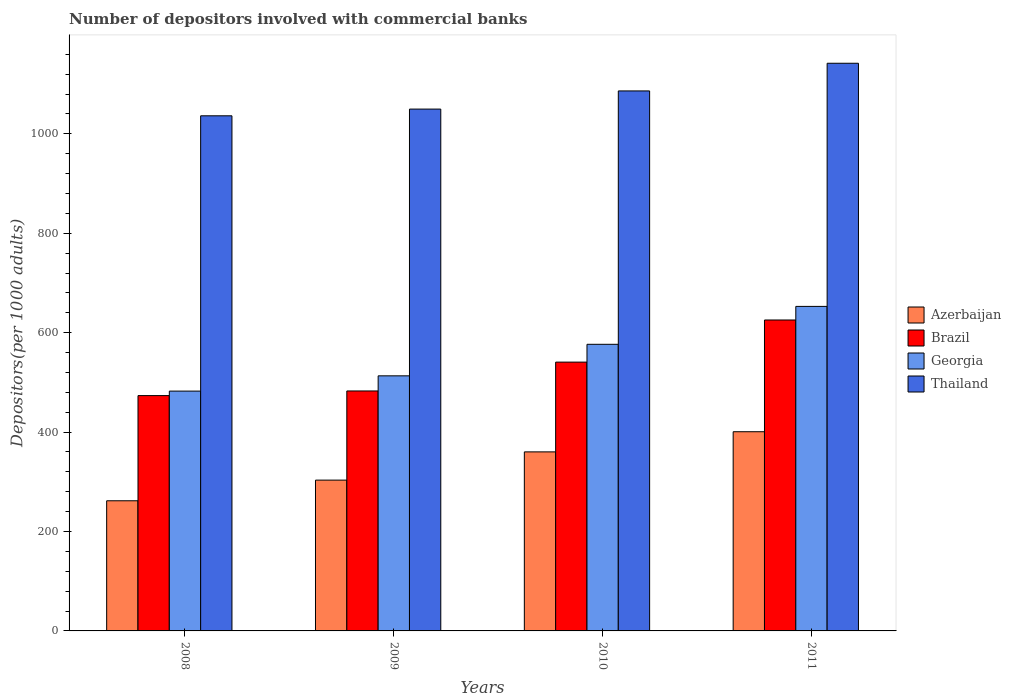How many different coloured bars are there?
Provide a short and direct response. 4. Are the number of bars on each tick of the X-axis equal?
Your answer should be very brief. Yes. How many bars are there on the 4th tick from the left?
Give a very brief answer. 4. In how many cases, is the number of bars for a given year not equal to the number of legend labels?
Ensure brevity in your answer.  0. What is the number of depositors involved with commercial banks in Thailand in 2010?
Provide a short and direct response. 1086.36. Across all years, what is the maximum number of depositors involved with commercial banks in Georgia?
Make the answer very short. 652.89. Across all years, what is the minimum number of depositors involved with commercial banks in Georgia?
Your answer should be compact. 482.47. In which year was the number of depositors involved with commercial banks in Brazil maximum?
Give a very brief answer. 2011. What is the total number of depositors involved with commercial banks in Brazil in the graph?
Make the answer very short. 2122.49. What is the difference between the number of depositors involved with commercial banks in Azerbaijan in 2010 and that in 2011?
Your answer should be very brief. -40.54. What is the difference between the number of depositors involved with commercial banks in Thailand in 2008 and the number of depositors involved with commercial banks in Brazil in 2009?
Your answer should be compact. 553.57. What is the average number of depositors involved with commercial banks in Azerbaijan per year?
Provide a short and direct response. 331.54. In the year 2009, what is the difference between the number of depositors involved with commercial banks in Thailand and number of depositors involved with commercial banks in Azerbaijan?
Provide a succinct answer. 746.44. What is the ratio of the number of depositors involved with commercial banks in Azerbaijan in 2008 to that in 2010?
Offer a terse response. 0.73. Is the number of depositors involved with commercial banks in Azerbaijan in 2008 less than that in 2011?
Offer a very short reply. Yes. What is the difference between the highest and the second highest number of depositors involved with commercial banks in Brazil?
Your answer should be compact. 84.74. What is the difference between the highest and the lowest number of depositors involved with commercial banks in Georgia?
Provide a short and direct response. 170.42. In how many years, is the number of depositors involved with commercial banks in Brazil greater than the average number of depositors involved with commercial banks in Brazil taken over all years?
Provide a succinct answer. 2. Is the sum of the number of depositors involved with commercial banks in Brazil in 2008 and 2011 greater than the maximum number of depositors involved with commercial banks in Azerbaijan across all years?
Make the answer very short. Yes. What does the 2nd bar from the right in 2011 represents?
Your response must be concise. Georgia. Does the graph contain any zero values?
Your answer should be compact. No. Does the graph contain grids?
Make the answer very short. No. How many legend labels are there?
Offer a very short reply. 4. How are the legend labels stacked?
Ensure brevity in your answer.  Vertical. What is the title of the graph?
Give a very brief answer. Number of depositors involved with commercial banks. Does "Jamaica" appear as one of the legend labels in the graph?
Provide a succinct answer. No. What is the label or title of the X-axis?
Provide a short and direct response. Years. What is the label or title of the Y-axis?
Your answer should be very brief. Depositors(per 1000 adults). What is the Depositors(per 1000 adults) of Azerbaijan in 2008?
Your response must be concise. 261.83. What is the Depositors(per 1000 adults) of Brazil in 2008?
Make the answer very short. 473.42. What is the Depositors(per 1000 adults) in Georgia in 2008?
Keep it short and to the point. 482.47. What is the Depositors(per 1000 adults) of Thailand in 2008?
Give a very brief answer. 1036.31. What is the Depositors(per 1000 adults) in Azerbaijan in 2009?
Provide a short and direct response. 303.38. What is the Depositors(per 1000 adults) in Brazil in 2009?
Offer a very short reply. 482.74. What is the Depositors(per 1000 adults) in Georgia in 2009?
Ensure brevity in your answer.  513.17. What is the Depositors(per 1000 adults) in Thailand in 2009?
Make the answer very short. 1049.83. What is the Depositors(per 1000 adults) of Azerbaijan in 2010?
Offer a terse response. 360.2. What is the Depositors(per 1000 adults) of Brazil in 2010?
Make the answer very short. 540.79. What is the Depositors(per 1000 adults) in Georgia in 2010?
Provide a succinct answer. 576.61. What is the Depositors(per 1000 adults) in Thailand in 2010?
Keep it short and to the point. 1086.36. What is the Depositors(per 1000 adults) of Azerbaijan in 2011?
Your answer should be very brief. 400.73. What is the Depositors(per 1000 adults) in Brazil in 2011?
Keep it short and to the point. 625.53. What is the Depositors(per 1000 adults) of Georgia in 2011?
Make the answer very short. 652.89. What is the Depositors(per 1000 adults) of Thailand in 2011?
Your answer should be compact. 1142.03. Across all years, what is the maximum Depositors(per 1000 adults) of Azerbaijan?
Offer a very short reply. 400.73. Across all years, what is the maximum Depositors(per 1000 adults) of Brazil?
Keep it short and to the point. 625.53. Across all years, what is the maximum Depositors(per 1000 adults) of Georgia?
Your answer should be very brief. 652.89. Across all years, what is the maximum Depositors(per 1000 adults) of Thailand?
Give a very brief answer. 1142.03. Across all years, what is the minimum Depositors(per 1000 adults) of Azerbaijan?
Your response must be concise. 261.83. Across all years, what is the minimum Depositors(per 1000 adults) of Brazil?
Provide a short and direct response. 473.42. Across all years, what is the minimum Depositors(per 1000 adults) of Georgia?
Ensure brevity in your answer.  482.47. Across all years, what is the minimum Depositors(per 1000 adults) of Thailand?
Keep it short and to the point. 1036.31. What is the total Depositors(per 1000 adults) of Azerbaijan in the graph?
Make the answer very short. 1326.14. What is the total Depositors(per 1000 adults) in Brazil in the graph?
Offer a terse response. 2122.49. What is the total Depositors(per 1000 adults) of Georgia in the graph?
Keep it short and to the point. 2225.13. What is the total Depositors(per 1000 adults) in Thailand in the graph?
Provide a succinct answer. 4314.52. What is the difference between the Depositors(per 1000 adults) in Azerbaijan in 2008 and that in 2009?
Make the answer very short. -41.55. What is the difference between the Depositors(per 1000 adults) in Brazil in 2008 and that in 2009?
Provide a short and direct response. -9.32. What is the difference between the Depositors(per 1000 adults) of Georgia in 2008 and that in 2009?
Make the answer very short. -30.7. What is the difference between the Depositors(per 1000 adults) of Thailand in 2008 and that in 2009?
Keep it short and to the point. -13.52. What is the difference between the Depositors(per 1000 adults) of Azerbaijan in 2008 and that in 2010?
Keep it short and to the point. -98.36. What is the difference between the Depositors(per 1000 adults) of Brazil in 2008 and that in 2010?
Make the answer very short. -67.37. What is the difference between the Depositors(per 1000 adults) in Georgia in 2008 and that in 2010?
Provide a succinct answer. -94.14. What is the difference between the Depositors(per 1000 adults) in Thailand in 2008 and that in 2010?
Your answer should be compact. -50.05. What is the difference between the Depositors(per 1000 adults) in Azerbaijan in 2008 and that in 2011?
Give a very brief answer. -138.9. What is the difference between the Depositors(per 1000 adults) of Brazil in 2008 and that in 2011?
Your answer should be compact. -152.11. What is the difference between the Depositors(per 1000 adults) in Georgia in 2008 and that in 2011?
Provide a succinct answer. -170.42. What is the difference between the Depositors(per 1000 adults) of Thailand in 2008 and that in 2011?
Your answer should be compact. -105.72. What is the difference between the Depositors(per 1000 adults) of Azerbaijan in 2009 and that in 2010?
Offer a terse response. -56.81. What is the difference between the Depositors(per 1000 adults) of Brazil in 2009 and that in 2010?
Your answer should be compact. -58.05. What is the difference between the Depositors(per 1000 adults) in Georgia in 2009 and that in 2010?
Provide a succinct answer. -63.44. What is the difference between the Depositors(per 1000 adults) of Thailand in 2009 and that in 2010?
Offer a terse response. -36.53. What is the difference between the Depositors(per 1000 adults) in Azerbaijan in 2009 and that in 2011?
Your answer should be very brief. -97.35. What is the difference between the Depositors(per 1000 adults) in Brazil in 2009 and that in 2011?
Keep it short and to the point. -142.79. What is the difference between the Depositors(per 1000 adults) of Georgia in 2009 and that in 2011?
Offer a terse response. -139.72. What is the difference between the Depositors(per 1000 adults) in Thailand in 2009 and that in 2011?
Ensure brevity in your answer.  -92.2. What is the difference between the Depositors(per 1000 adults) of Azerbaijan in 2010 and that in 2011?
Provide a succinct answer. -40.54. What is the difference between the Depositors(per 1000 adults) of Brazil in 2010 and that in 2011?
Keep it short and to the point. -84.74. What is the difference between the Depositors(per 1000 adults) in Georgia in 2010 and that in 2011?
Give a very brief answer. -76.28. What is the difference between the Depositors(per 1000 adults) in Thailand in 2010 and that in 2011?
Provide a succinct answer. -55.66. What is the difference between the Depositors(per 1000 adults) in Azerbaijan in 2008 and the Depositors(per 1000 adults) in Brazil in 2009?
Offer a very short reply. -220.91. What is the difference between the Depositors(per 1000 adults) in Azerbaijan in 2008 and the Depositors(per 1000 adults) in Georgia in 2009?
Offer a terse response. -251.33. What is the difference between the Depositors(per 1000 adults) in Azerbaijan in 2008 and the Depositors(per 1000 adults) in Thailand in 2009?
Give a very brief answer. -788. What is the difference between the Depositors(per 1000 adults) in Brazil in 2008 and the Depositors(per 1000 adults) in Georgia in 2009?
Give a very brief answer. -39.74. What is the difference between the Depositors(per 1000 adults) in Brazil in 2008 and the Depositors(per 1000 adults) in Thailand in 2009?
Provide a succinct answer. -576.41. What is the difference between the Depositors(per 1000 adults) in Georgia in 2008 and the Depositors(per 1000 adults) in Thailand in 2009?
Ensure brevity in your answer.  -567.36. What is the difference between the Depositors(per 1000 adults) of Azerbaijan in 2008 and the Depositors(per 1000 adults) of Brazil in 2010?
Make the answer very short. -278.96. What is the difference between the Depositors(per 1000 adults) in Azerbaijan in 2008 and the Depositors(per 1000 adults) in Georgia in 2010?
Your answer should be very brief. -314.78. What is the difference between the Depositors(per 1000 adults) of Azerbaijan in 2008 and the Depositors(per 1000 adults) of Thailand in 2010?
Your answer should be very brief. -824.53. What is the difference between the Depositors(per 1000 adults) in Brazil in 2008 and the Depositors(per 1000 adults) in Georgia in 2010?
Offer a very short reply. -103.19. What is the difference between the Depositors(per 1000 adults) in Brazil in 2008 and the Depositors(per 1000 adults) in Thailand in 2010?
Your answer should be compact. -612.94. What is the difference between the Depositors(per 1000 adults) in Georgia in 2008 and the Depositors(per 1000 adults) in Thailand in 2010?
Your answer should be compact. -603.89. What is the difference between the Depositors(per 1000 adults) in Azerbaijan in 2008 and the Depositors(per 1000 adults) in Brazil in 2011?
Offer a very short reply. -363.7. What is the difference between the Depositors(per 1000 adults) of Azerbaijan in 2008 and the Depositors(per 1000 adults) of Georgia in 2011?
Give a very brief answer. -391.05. What is the difference between the Depositors(per 1000 adults) in Azerbaijan in 2008 and the Depositors(per 1000 adults) in Thailand in 2011?
Offer a terse response. -880.19. What is the difference between the Depositors(per 1000 adults) of Brazil in 2008 and the Depositors(per 1000 adults) of Georgia in 2011?
Ensure brevity in your answer.  -179.46. What is the difference between the Depositors(per 1000 adults) in Brazil in 2008 and the Depositors(per 1000 adults) in Thailand in 2011?
Offer a very short reply. -668.6. What is the difference between the Depositors(per 1000 adults) of Georgia in 2008 and the Depositors(per 1000 adults) of Thailand in 2011?
Ensure brevity in your answer.  -659.56. What is the difference between the Depositors(per 1000 adults) of Azerbaijan in 2009 and the Depositors(per 1000 adults) of Brazil in 2010?
Your answer should be compact. -237.41. What is the difference between the Depositors(per 1000 adults) in Azerbaijan in 2009 and the Depositors(per 1000 adults) in Georgia in 2010?
Make the answer very short. -273.22. What is the difference between the Depositors(per 1000 adults) in Azerbaijan in 2009 and the Depositors(per 1000 adults) in Thailand in 2010?
Make the answer very short. -782.98. What is the difference between the Depositors(per 1000 adults) of Brazil in 2009 and the Depositors(per 1000 adults) of Georgia in 2010?
Provide a short and direct response. -93.87. What is the difference between the Depositors(per 1000 adults) of Brazil in 2009 and the Depositors(per 1000 adults) of Thailand in 2010?
Your response must be concise. -603.62. What is the difference between the Depositors(per 1000 adults) in Georgia in 2009 and the Depositors(per 1000 adults) in Thailand in 2010?
Your answer should be compact. -573.2. What is the difference between the Depositors(per 1000 adults) of Azerbaijan in 2009 and the Depositors(per 1000 adults) of Brazil in 2011?
Your response must be concise. -322.15. What is the difference between the Depositors(per 1000 adults) of Azerbaijan in 2009 and the Depositors(per 1000 adults) of Georgia in 2011?
Keep it short and to the point. -349.5. What is the difference between the Depositors(per 1000 adults) of Azerbaijan in 2009 and the Depositors(per 1000 adults) of Thailand in 2011?
Your answer should be very brief. -838.64. What is the difference between the Depositors(per 1000 adults) of Brazil in 2009 and the Depositors(per 1000 adults) of Georgia in 2011?
Make the answer very short. -170.15. What is the difference between the Depositors(per 1000 adults) of Brazil in 2009 and the Depositors(per 1000 adults) of Thailand in 2011?
Ensure brevity in your answer.  -659.29. What is the difference between the Depositors(per 1000 adults) of Georgia in 2009 and the Depositors(per 1000 adults) of Thailand in 2011?
Keep it short and to the point. -628.86. What is the difference between the Depositors(per 1000 adults) in Azerbaijan in 2010 and the Depositors(per 1000 adults) in Brazil in 2011?
Provide a succinct answer. -265.34. What is the difference between the Depositors(per 1000 adults) of Azerbaijan in 2010 and the Depositors(per 1000 adults) of Georgia in 2011?
Ensure brevity in your answer.  -292.69. What is the difference between the Depositors(per 1000 adults) of Azerbaijan in 2010 and the Depositors(per 1000 adults) of Thailand in 2011?
Give a very brief answer. -781.83. What is the difference between the Depositors(per 1000 adults) in Brazil in 2010 and the Depositors(per 1000 adults) in Georgia in 2011?
Offer a terse response. -112.09. What is the difference between the Depositors(per 1000 adults) of Brazil in 2010 and the Depositors(per 1000 adults) of Thailand in 2011?
Make the answer very short. -601.23. What is the difference between the Depositors(per 1000 adults) of Georgia in 2010 and the Depositors(per 1000 adults) of Thailand in 2011?
Your answer should be compact. -565.42. What is the average Depositors(per 1000 adults) of Azerbaijan per year?
Keep it short and to the point. 331.54. What is the average Depositors(per 1000 adults) in Brazil per year?
Your response must be concise. 530.62. What is the average Depositors(per 1000 adults) in Georgia per year?
Keep it short and to the point. 556.28. What is the average Depositors(per 1000 adults) of Thailand per year?
Offer a terse response. 1078.63. In the year 2008, what is the difference between the Depositors(per 1000 adults) in Azerbaijan and Depositors(per 1000 adults) in Brazil?
Give a very brief answer. -211.59. In the year 2008, what is the difference between the Depositors(per 1000 adults) of Azerbaijan and Depositors(per 1000 adults) of Georgia?
Ensure brevity in your answer.  -220.64. In the year 2008, what is the difference between the Depositors(per 1000 adults) in Azerbaijan and Depositors(per 1000 adults) in Thailand?
Offer a very short reply. -774.48. In the year 2008, what is the difference between the Depositors(per 1000 adults) in Brazil and Depositors(per 1000 adults) in Georgia?
Offer a terse response. -9.05. In the year 2008, what is the difference between the Depositors(per 1000 adults) in Brazil and Depositors(per 1000 adults) in Thailand?
Offer a very short reply. -562.89. In the year 2008, what is the difference between the Depositors(per 1000 adults) of Georgia and Depositors(per 1000 adults) of Thailand?
Provide a short and direct response. -553.84. In the year 2009, what is the difference between the Depositors(per 1000 adults) of Azerbaijan and Depositors(per 1000 adults) of Brazil?
Keep it short and to the point. -179.36. In the year 2009, what is the difference between the Depositors(per 1000 adults) of Azerbaijan and Depositors(per 1000 adults) of Georgia?
Offer a very short reply. -209.78. In the year 2009, what is the difference between the Depositors(per 1000 adults) of Azerbaijan and Depositors(per 1000 adults) of Thailand?
Make the answer very short. -746.44. In the year 2009, what is the difference between the Depositors(per 1000 adults) in Brazil and Depositors(per 1000 adults) in Georgia?
Your answer should be compact. -30.43. In the year 2009, what is the difference between the Depositors(per 1000 adults) of Brazil and Depositors(per 1000 adults) of Thailand?
Offer a terse response. -567.09. In the year 2009, what is the difference between the Depositors(per 1000 adults) in Georgia and Depositors(per 1000 adults) in Thailand?
Provide a succinct answer. -536.66. In the year 2010, what is the difference between the Depositors(per 1000 adults) in Azerbaijan and Depositors(per 1000 adults) in Brazil?
Give a very brief answer. -180.6. In the year 2010, what is the difference between the Depositors(per 1000 adults) of Azerbaijan and Depositors(per 1000 adults) of Georgia?
Provide a succinct answer. -216.41. In the year 2010, what is the difference between the Depositors(per 1000 adults) of Azerbaijan and Depositors(per 1000 adults) of Thailand?
Your response must be concise. -726.17. In the year 2010, what is the difference between the Depositors(per 1000 adults) in Brazil and Depositors(per 1000 adults) in Georgia?
Your response must be concise. -35.82. In the year 2010, what is the difference between the Depositors(per 1000 adults) of Brazil and Depositors(per 1000 adults) of Thailand?
Offer a terse response. -545.57. In the year 2010, what is the difference between the Depositors(per 1000 adults) in Georgia and Depositors(per 1000 adults) in Thailand?
Offer a very short reply. -509.75. In the year 2011, what is the difference between the Depositors(per 1000 adults) of Azerbaijan and Depositors(per 1000 adults) of Brazil?
Your answer should be compact. -224.8. In the year 2011, what is the difference between the Depositors(per 1000 adults) in Azerbaijan and Depositors(per 1000 adults) in Georgia?
Your answer should be very brief. -252.15. In the year 2011, what is the difference between the Depositors(per 1000 adults) in Azerbaijan and Depositors(per 1000 adults) in Thailand?
Give a very brief answer. -741.29. In the year 2011, what is the difference between the Depositors(per 1000 adults) in Brazil and Depositors(per 1000 adults) in Georgia?
Your response must be concise. -27.35. In the year 2011, what is the difference between the Depositors(per 1000 adults) of Brazil and Depositors(per 1000 adults) of Thailand?
Give a very brief answer. -516.49. In the year 2011, what is the difference between the Depositors(per 1000 adults) in Georgia and Depositors(per 1000 adults) in Thailand?
Offer a very short reply. -489.14. What is the ratio of the Depositors(per 1000 adults) in Azerbaijan in 2008 to that in 2009?
Offer a terse response. 0.86. What is the ratio of the Depositors(per 1000 adults) in Brazil in 2008 to that in 2009?
Your answer should be very brief. 0.98. What is the ratio of the Depositors(per 1000 adults) of Georgia in 2008 to that in 2009?
Offer a terse response. 0.94. What is the ratio of the Depositors(per 1000 adults) of Thailand in 2008 to that in 2009?
Ensure brevity in your answer.  0.99. What is the ratio of the Depositors(per 1000 adults) in Azerbaijan in 2008 to that in 2010?
Your answer should be compact. 0.73. What is the ratio of the Depositors(per 1000 adults) in Brazil in 2008 to that in 2010?
Provide a succinct answer. 0.88. What is the ratio of the Depositors(per 1000 adults) in Georgia in 2008 to that in 2010?
Ensure brevity in your answer.  0.84. What is the ratio of the Depositors(per 1000 adults) of Thailand in 2008 to that in 2010?
Your response must be concise. 0.95. What is the ratio of the Depositors(per 1000 adults) in Azerbaijan in 2008 to that in 2011?
Provide a short and direct response. 0.65. What is the ratio of the Depositors(per 1000 adults) in Brazil in 2008 to that in 2011?
Ensure brevity in your answer.  0.76. What is the ratio of the Depositors(per 1000 adults) of Georgia in 2008 to that in 2011?
Your response must be concise. 0.74. What is the ratio of the Depositors(per 1000 adults) in Thailand in 2008 to that in 2011?
Ensure brevity in your answer.  0.91. What is the ratio of the Depositors(per 1000 adults) of Azerbaijan in 2009 to that in 2010?
Provide a succinct answer. 0.84. What is the ratio of the Depositors(per 1000 adults) in Brazil in 2009 to that in 2010?
Ensure brevity in your answer.  0.89. What is the ratio of the Depositors(per 1000 adults) in Georgia in 2009 to that in 2010?
Your response must be concise. 0.89. What is the ratio of the Depositors(per 1000 adults) of Thailand in 2009 to that in 2010?
Your answer should be compact. 0.97. What is the ratio of the Depositors(per 1000 adults) of Azerbaijan in 2009 to that in 2011?
Your response must be concise. 0.76. What is the ratio of the Depositors(per 1000 adults) in Brazil in 2009 to that in 2011?
Your response must be concise. 0.77. What is the ratio of the Depositors(per 1000 adults) of Georgia in 2009 to that in 2011?
Your response must be concise. 0.79. What is the ratio of the Depositors(per 1000 adults) in Thailand in 2009 to that in 2011?
Provide a short and direct response. 0.92. What is the ratio of the Depositors(per 1000 adults) of Azerbaijan in 2010 to that in 2011?
Provide a short and direct response. 0.9. What is the ratio of the Depositors(per 1000 adults) in Brazil in 2010 to that in 2011?
Give a very brief answer. 0.86. What is the ratio of the Depositors(per 1000 adults) in Georgia in 2010 to that in 2011?
Give a very brief answer. 0.88. What is the ratio of the Depositors(per 1000 adults) of Thailand in 2010 to that in 2011?
Give a very brief answer. 0.95. What is the difference between the highest and the second highest Depositors(per 1000 adults) of Azerbaijan?
Provide a succinct answer. 40.54. What is the difference between the highest and the second highest Depositors(per 1000 adults) of Brazil?
Ensure brevity in your answer.  84.74. What is the difference between the highest and the second highest Depositors(per 1000 adults) in Georgia?
Offer a very short reply. 76.28. What is the difference between the highest and the second highest Depositors(per 1000 adults) in Thailand?
Make the answer very short. 55.66. What is the difference between the highest and the lowest Depositors(per 1000 adults) of Azerbaijan?
Provide a short and direct response. 138.9. What is the difference between the highest and the lowest Depositors(per 1000 adults) of Brazil?
Offer a very short reply. 152.11. What is the difference between the highest and the lowest Depositors(per 1000 adults) in Georgia?
Offer a terse response. 170.42. What is the difference between the highest and the lowest Depositors(per 1000 adults) of Thailand?
Your response must be concise. 105.72. 